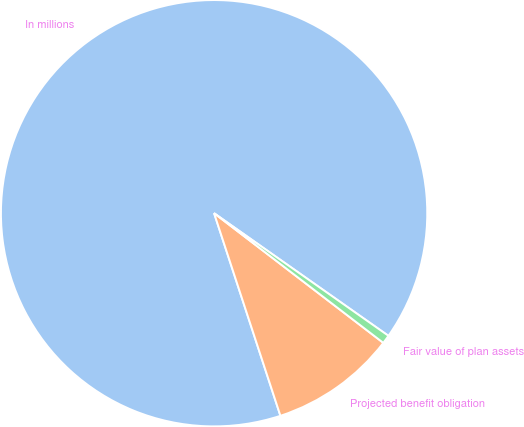<chart> <loc_0><loc_0><loc_500><loc_500><pie_chart><fcel>In millions<fcel>Projected benefit obligation<fcel>Fair value of plan assets<nl><fcel>89.79%<fcel>9.56%<fcel>0.65%<nl></chart> 